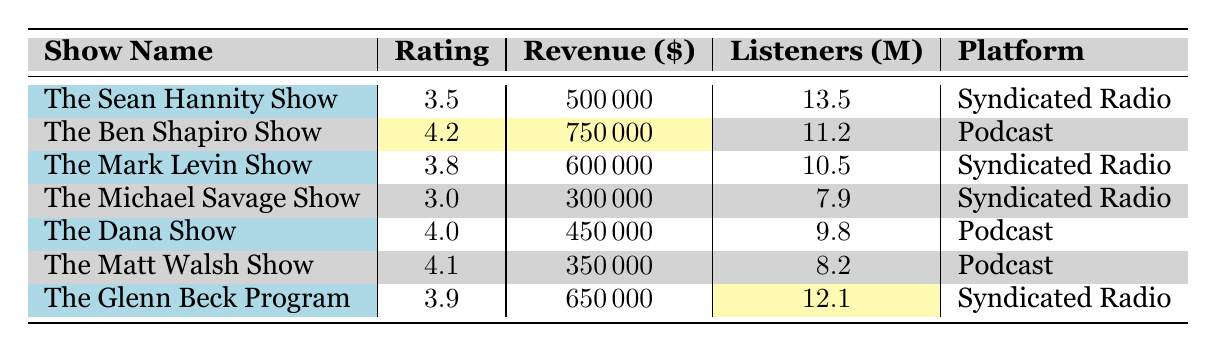What is the average rating of all conservative talk shows listed? To find the average rating, sum all the ratings: 3.5 + 4.2 + 3.8 + 3.0 + 4.0 + 4.1 + 3.9 = 26.5. There are 7 shows, so the average rating is 26.5 / 7 = 3.79.
Answer: 3.79 Which show has the highest monthly revenue? The table directly presents the monthly revenue for each show. The Ben Shapiro Show has the highest revenue at $750,000.
Answer: The Ben Shapiro Show How many listeners does The Glenn Beck Program have? The table lists 12.1 million listeners for The Glenn Beck Program.
Answer: 12.1 million Is The Michael Savage Show among the top three shows by average rating? The average ratings of the shows are: 3.5, 4.2, 3.8, 3.0, 4.0, 4.1, and 3.9. The top three ratings are 4.2, 4.1, and 4.0, placing The Michael Savage Show in 6th place. Therefore, the answer is no.
Answer: No What is the total monthly revenue of all the shows combined? To find the total revenue, add each show’s monthly revenue: 500000 + 750000 + 600000 + 300000 + 450000 + 350000 + 650000 = 3200000.
Answer: $3,200,000 Which platform has the highest average rating based on the shows listed? Calculate the average ratings for each platform. For Syndicated Radio: (3.5 + 3.8 + 3.0 + 3.9) / 4 = 3.575; for Podcast: (4.2 + 4.0 + 4.1) / 3 = 4.133. The Podcast platform has a higher average rating.
Answer: Podcast How much revenue does The Dana Show generate? The table states The Dana Show generates $450,000 monthly revenue.
Answer: $450,000 Which show has the least number of listeners, and how many are there? The table lists the number of listeners for each show. The Michael Savage Show has the least with 7.9 million listeners.
Answer: The Michael Savage Show, 7.9 million What is the difference in monthly revenue between The Ben Shapiro Show and The Matt Walsh Show? The Ben Shapiro Show generates $750,000, and The Matt Walsh Show generates $350,000. The difference is $750,000 - $350,000 = $400,000.
Answer: $400,000 Is the average rating of The Sean Hannity Show higher than that of The Dana Show? The Sean Hannity Show has a rating of 3.5 and The Dana Show has a rating of 4.0. Since 3.5 is less than 4.0, the answer is no.
Answer: No 